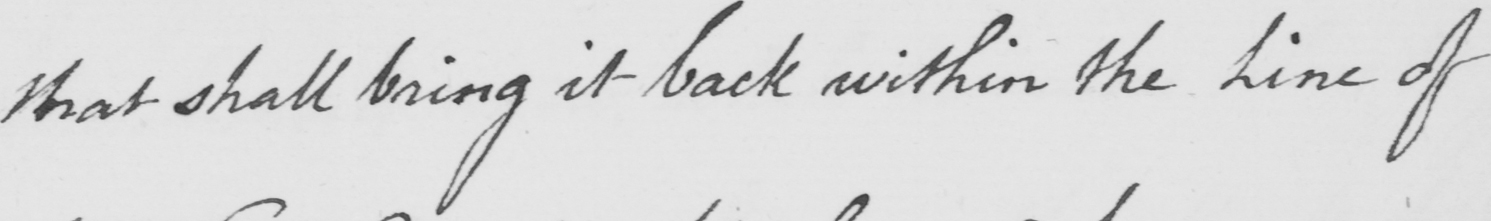What text is written in this handwritten line? that shall bring it back within the Line of 